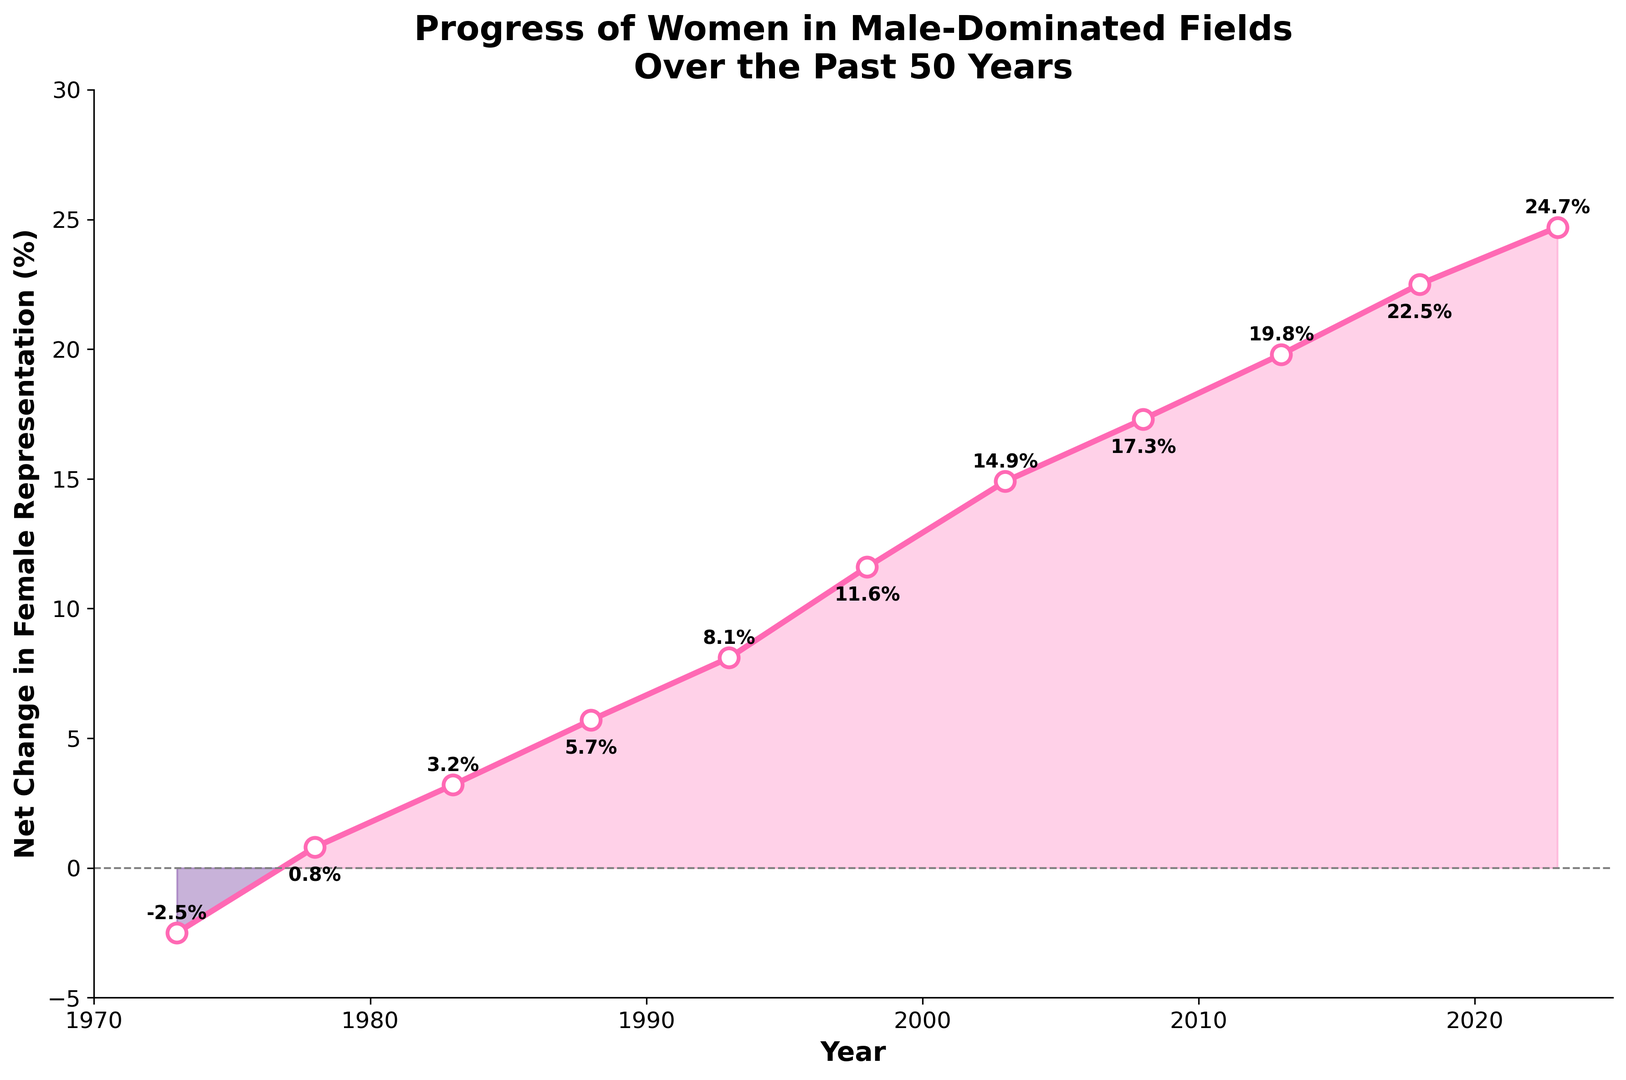What's the total increase in female representation from 1973 to 2023? To find the total increase in female representation over these years, subtract the female representation in 1973 from the representation in 2023. The calculation is 24.7 - (-2.5). First, convert -2.5 to positive by adding, which gives 24.7 + 2.5.
Answer: 27.2% In which year did female representation see the highest net change? By observing the plot, we look for the highest point on the line. This peak is in the year 2023, with a net change of 24.7%.
Answer: 2023 What is the average net change in female representation from 1983 to 2013? To calculate the average net change, sum the net changes from 1983 to 2013 and then divide by the number of data points: (3.2 + 5.7 + 8.1 + 11.6 + 14.9 + 17.3 + 19.8) / 7. The sum is 80.6, and there are 7 data points. Therefore, 80.6 / 7 is approximately 11.51.
Answer: 11.51% Between which years did female representation change from negative to positive? Identify the year when the line crosses the x-axis (y=0). Female representation changes from negative to positive between 1973 and 1978.
Answer: 1973 and 1978 Which decade had the most significant increase in female representation? By comparing the changes in decade intervals: The 1990s (1993 to 2003) saw an increase from 8.1% to 14.9%, a 6.8% increase, and the 2000s (2003 to 2013) saw an increase from 14.9% to 19.8%, a 4.9% increase. The largest increase occurred in the 1980s (1978 to 1988), from 0.8% to 5.7%, which is a 4.9% increase.
Answer: 1990s What color is used to depict positive changes in female representation? The plot illustrates positive changes with pink shading under the line where values are above zero.
Answer: pink How many years show a net negative change in female representation? The line dips below zero only in 1973. Based on the visual data, only one year shows a negative net change.
Answer: 1 year By how much did female representation increase between 2008 and 2023? Observe the value at 2023 (24.7%) and subtract the value for 2008 (17.3%). The increase is 24.7 - 17.3 = 7.4%.
Answer: 7.4% What was the first year to show a double-digit increase in female representation? From the plot, look for the first year where the line crosses the 10% mark. This happens in 1998 with an increase of 11.6%.
Answer: 1998 